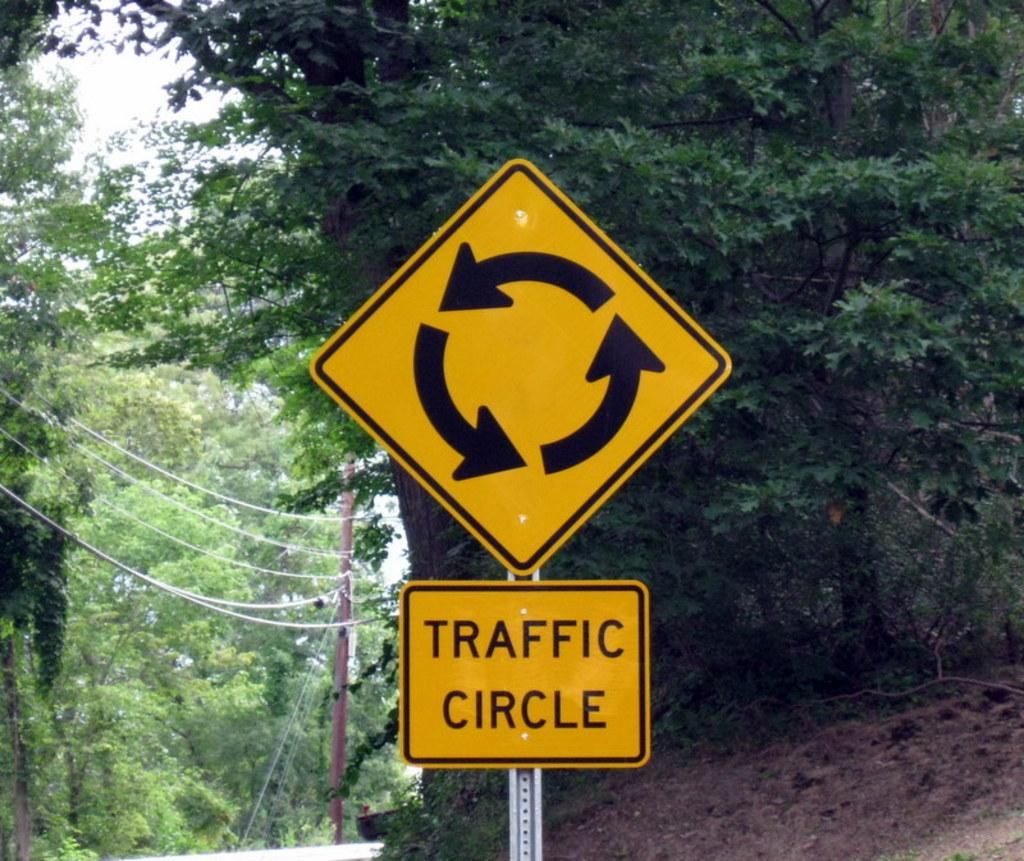<image>
Relay a brief, clear account of the picture shown. Yellow sign which says "traffic circle" on it. 